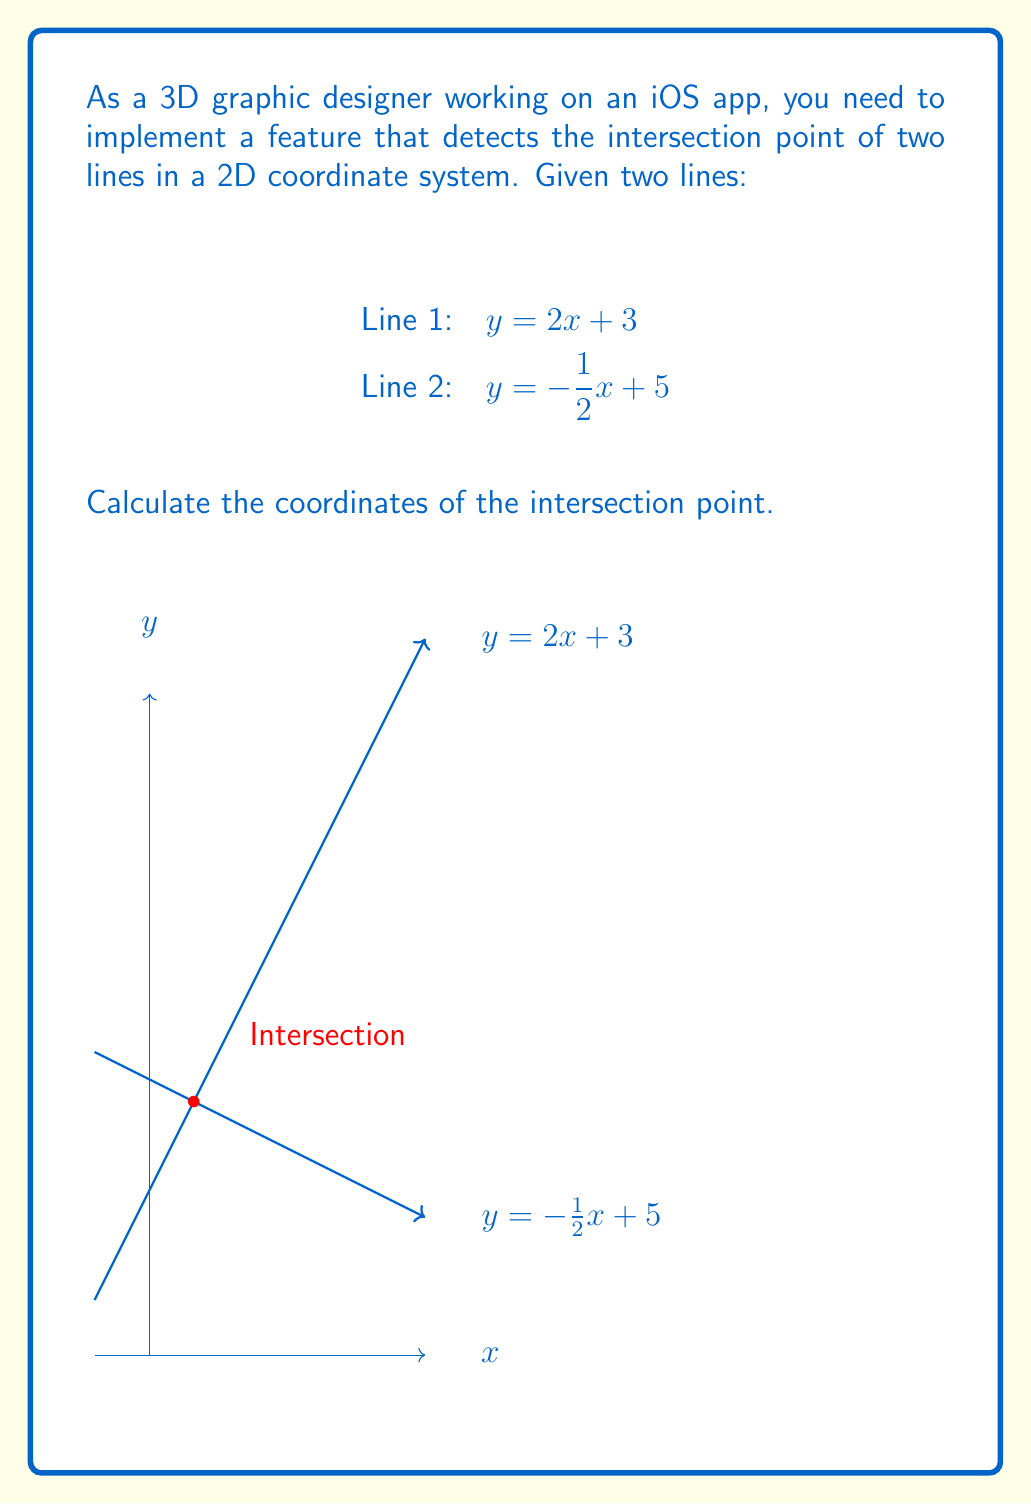Teach me how to tackle this problem. To find the intersection point of two lines, we need to solve the system of equations formed by the two line equations. Let's approach this step-by-step:

1) We have two equations:
   Line 1: $y = 2x + 3$
   Line 2: $y = -\frac{1}{2}x + 5$

2) At the intersection point, the $y$ values are equal, so we can set the right sides of the equations equal to each other:

   $2x + 3 = -\frac{1}{2}x + 5$

3) Now, let's solve for $x$:
   
   $2x + 3 = -\frac{1}{2}x + 5$
   $2x + \frac{1}{2}x = 5 - 3$
   $\frac{5}{2}x = 2$
   $x = \frac{4}{5} = 0.8$

4) Now that we know $x$, we can substitute it into either of the original equations to find $y$. Let's use the first equation:

   $y = 2x + 3$
   $y = 2(\frac{4}{5}) + 3$
   $y = \frac{8}{5} + 3$
   $y = \frac{8}{5} + \frac{15}{5}$
   $y = \frac{23}{5} = 2.2$

5) Therefore, the intersection point is $(\frac{4}{5}, \frac{11}{5})$ or $(0.8, 2.2)$.

This calculation is crucial for determining where two lines meet in your 2D coordinate system, which could be useful for various graphical operations in your iOS app.
Answer: $(\frac{4}{5}, \frac{11}{5})$ or $(0.8, 2.2)$ 